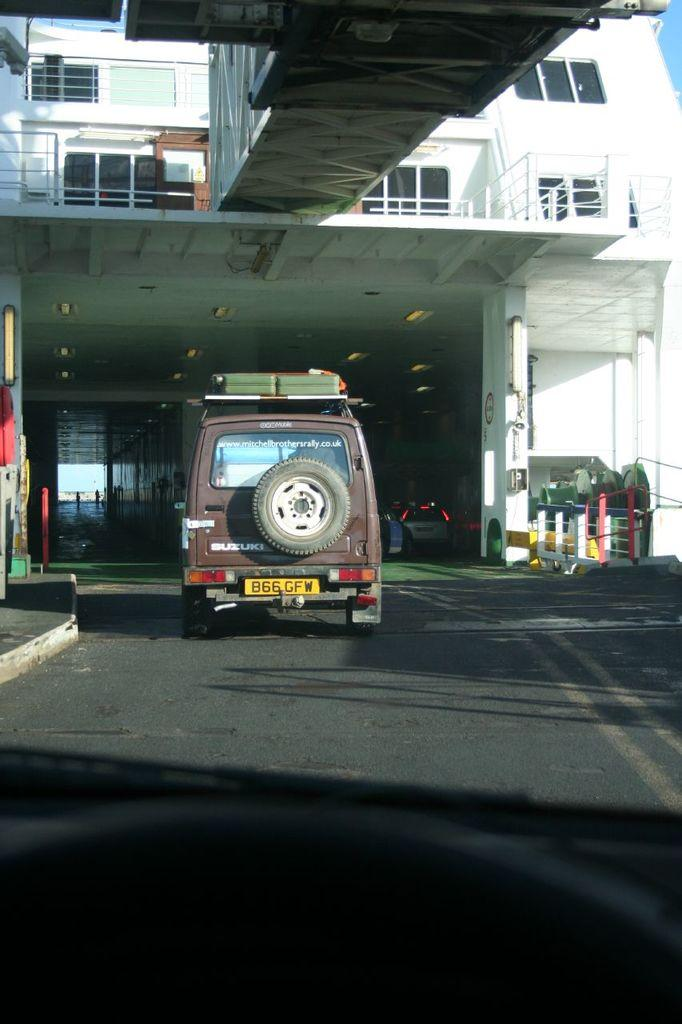What is happening in the image involving a vehicle? There is a vehicle moving on the road in the image. How is the road in the image positioned? The road is above another road. What type of structure can be seen in the image? There is a building in the image. What is present in front of the building? There is a bridge in front of the building. What type of lock is being used by the committee in the game depicted in the image? There is no lock, committee, or game present in the image. 